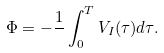Convert formula to latex. <formula><loc_0><loc_0><loc_500><loc_500>\Phi = - \frac { 1 } { } \int _ { 0 } ^ { T } V _ { I } ( \tau ) d \tau .</formula> 